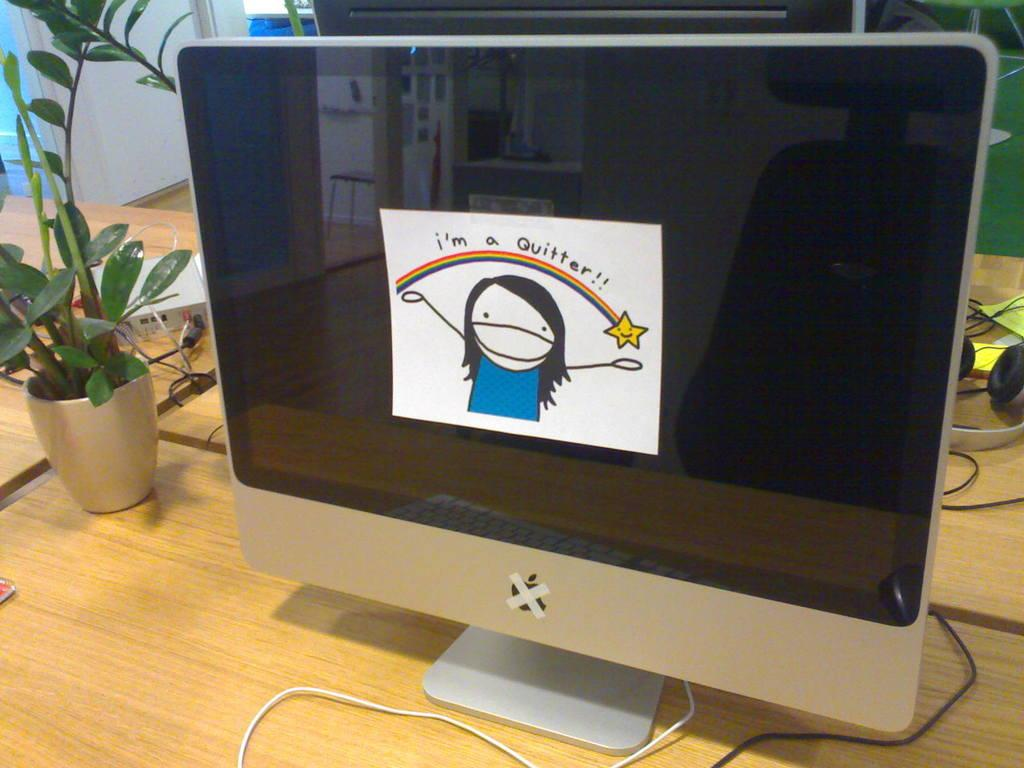What is the main object in the center of the image? There is a monitor screen in the center of the image. What other object can be seen in the image? There is a plant on a table in the image. What type of dust can be seen on the marble surface in the image? There is no marble surface present in the image, and therefore no dust can be observed. 